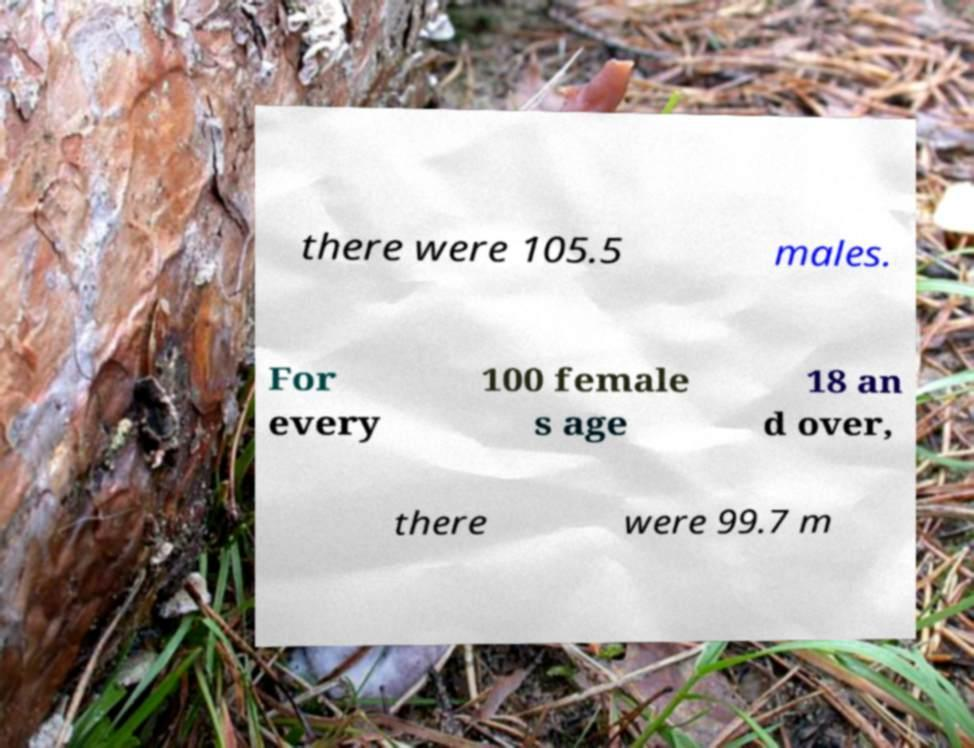Can you accurately transcribe the text from the provided image for me? there were 105.5 males. For every 100 female s age 18 an d over, there were 99.7 m 